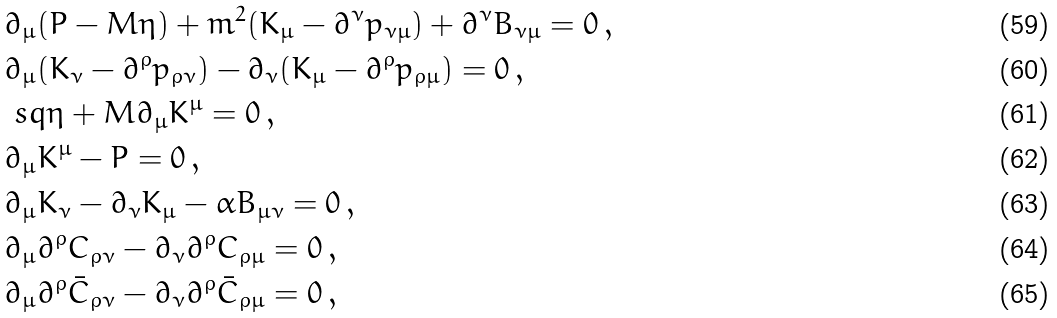<formula> <loc_0><loc_0><loc_500><loc_500>& \partial _ { \mu } ( P - M \eta ) + m ^ { 2 } ( K _ { \mu } - \partial ^ { \nu } p _ { \nu \mu } ) + \partial ^ { \nu } B _ { \nu \mu } = 0 \, , \\ & \partial _ { \mu } ( K _ { \nu } - \partial ^ { \rho } p _ { \rho \nu } ) - \partial _ { \nu } ( K _ { \mu } - \partial ^ { \rho } p _ { \rho \mu } ) = 0 \, , \\ & \ s q \eta + M \partial _ { \mu } K ^ { \mu } = 0 \, , \\ & \partial _ { \mu } K ^ { \mu } - P = 0 \, , \\ & \partial _ { \mu } K _ { \nu } - \partial _ { \nu } K _ { \mu } - \alpha B _ { \mu \nu } = 0 \, , \\ & \partial _ { \mu } \partial ^ { \rho } C _ { \rho \nu } - \partial _ { \nu } \partial ^ { \rho } C _ { \rho \mu } = 0 \, , \\ & \partial _ { \mu } \partial ^ { \rho } \bar { C } _ { \rho \nu } - \partial _ { \nu } \partial ^ { \rho } \bar { C } _ { \rho \mu } = 0 \, ,</formula> 